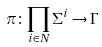Convert formula to latex. <formula><loc_0><loc_0><loc_500><loc_500>\pi \colon \prod _ { i \in N } \Sigma ^ { i } \rightarrow \Gamma</formula> 